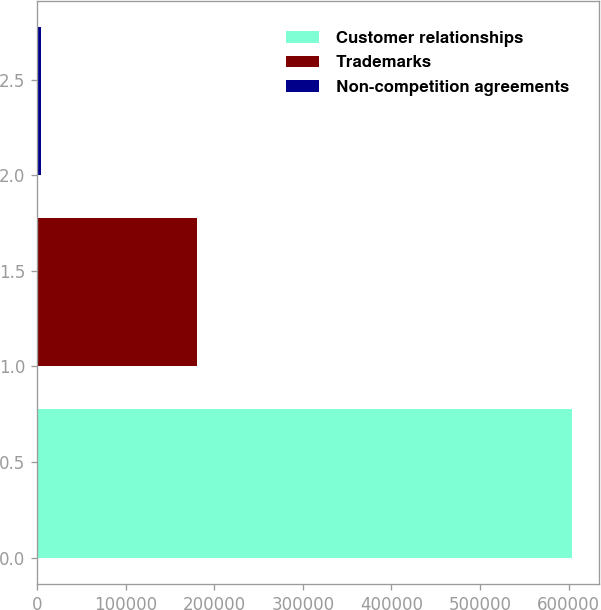<chart> <loc_0><loc_0><loc_500><loc_500><bar_chart><fcel>Customer relationships<fcel>Trademarks<fcel>Non-competition agreements<nl><fcel>603966<fcel>180416<fcel>5098<nl></chart> 